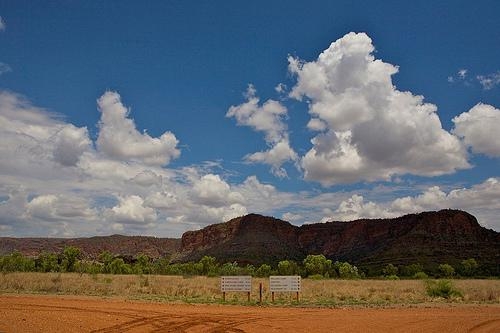Question: how do trees grow out there?
Choices:
A. Rain.
B. Someone planted them.
C. Sunshine.
D. They evolved to grow there.
Answer with the letter. Answer: A Question: what is in the sky?
Choices:
A. A helicopter.
B. A balloon.
C. Clouds.
D. An airplane.
Answer with the letter. Answer: C Question: why are there no street lights?
Choices:
A. No electricity.
B. A rural area.
C. It's not dark.
D. An empty highway.
Answer with the letter. Answer: B Question: where is this scene?
Choices:
A. Arizona.
B. A rocky plain.
C. A desert.
D. A beach.
Answer with the letter. Answer: C Question: what is the center?
Choices:
A. A tree.
B. A pole.
C. Two signs.
D. A billboard.
Answer with the letter. Answer: C Question: when is this?
Choices:
A. Noon.
B. Middle of the day.
C. Morning.
D. Nighttime.
Answer with the letter. Answer: B 